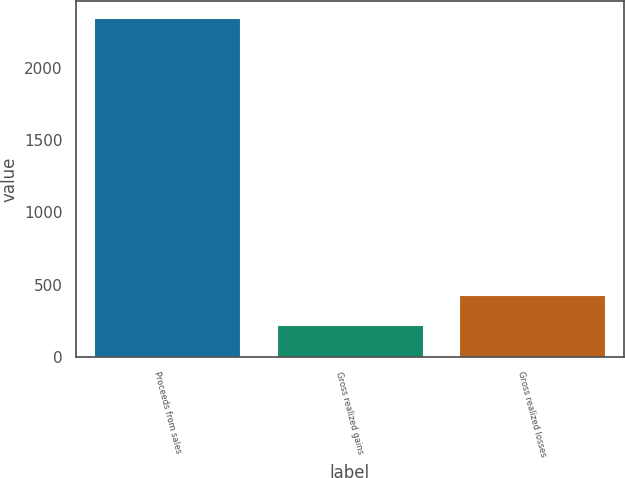Convert chart. <chart><loc_0><loc_0><loc_500><loc_500><bar_chart><fcel>Proceeds from sales<fcel>Gross realized gains<fcel>Gross realized losses<nl><fcel>2341<fcel>219<fcel>431.2<nl></chart> 